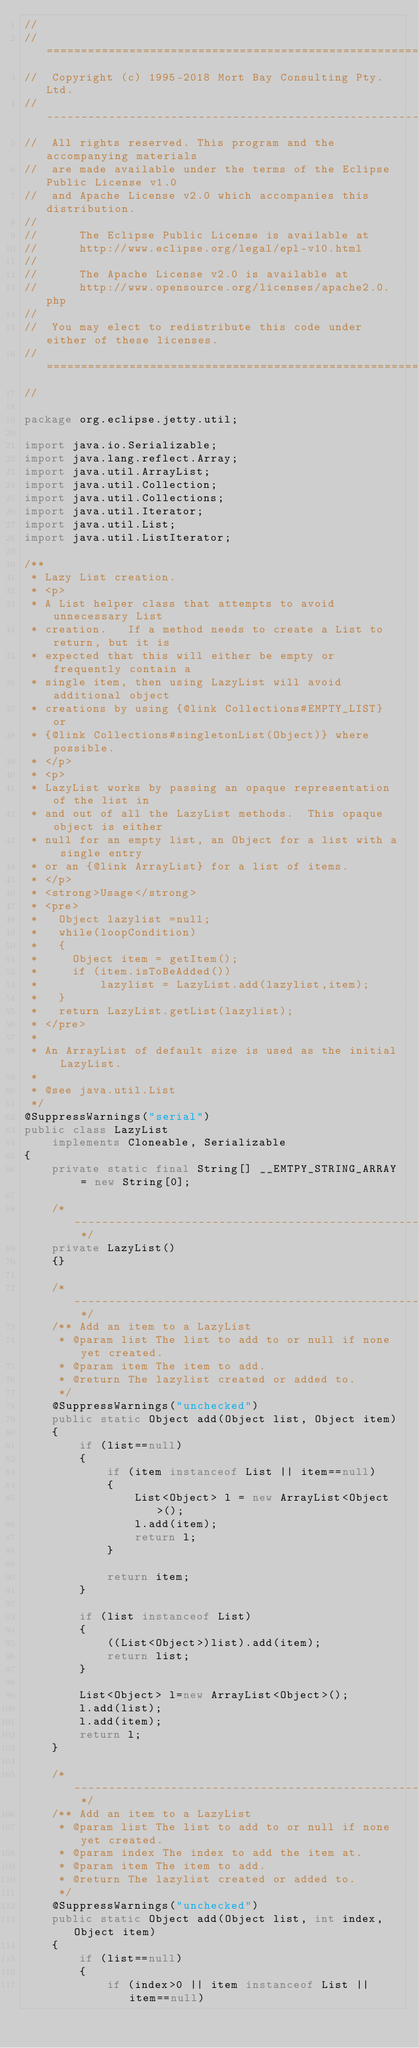<code> <loc_0><loc_0><loc_500><loc_500><_Java_>//
//  ========================================================================
//  Copyright (c) 1995-2018 Mort Bay Consulting Pty. Ltd.
//  ------------------------------------------------------------------------
//  All rights reserved. This program and the accompanying materials
//  are made available under the terms of the Eclipse Public License v1.0
//  and Apache License v2.0 which accompanies this distribution.
//
//      The Eclipse Public License is available at
//      http://www.eclipse.org/legal/epl-v10.html
//
//      The Apache License v2.0 is available at
//      http://www.opensource.org/licenses/apache2.0.php
//
//  You may elect to redistribute this code under either of these licenses.
//  ========================================================================
//

package org.eclipse.jetty.util;

import java.io.Serializable;
import java.lang.reflect.Array;
import java.util.ArrayList;
import java.util.Collection;
import java.util.Collections;
import java.util.Iterator;
import java.util.List;
import java.util.ListIterator;

/** 
 * Lazy List creation.
 * <p>
 * A List helper class that attempts to avoid unnecessary List
 * creation.   If a method needs to create a List to return, but it is
 * expected that this will either be empty or frequently contain a
 * single item, then using LazyList will avoid additional object
 * creations by using {@link Collections#EMPTY_LIST} or
 * {@link Collections#singletonList(Object)} where possible.
 * </p>
 * <p>
 * LazyList works by passing an opaque representation of the list in
 * and out of all the LazyList methods.  This opaque object is either
 * null for an empty list, an Object for a list with a single entry
 * or an {@link ArrayList} for a list of items.
 * </p>
 * <strong>Usage</strong>
 * <pre>
 *   Object lazylist =null;
 *   while(loopCondition)
 *   {
 *     Object item = getItem();
 *     if (item.isToBeAdded())
 *         lazylist = LazyList.add(lazylist,item);
 *   }
 *   return LazyList.getList(lazylist);
 * </pre>
 *
 * An ArrayList of default size is used as the initial LazyList.
 *
 * @see java.util.List
 */
@SuppressWarnings("serial")
public class LazyList
    implements Cloneable, Serializable
{
    private static final String[] __EMTPY_STRING_ARRAY = new String[0];
    
    /* ------------------------------------------------------------ */
    private LazyList()
    {}
    
    /* ------------------------------------------------------------ */
    /** Add an item to a LazyList 
     * @param list The list to add to or null if none yet created.
     * @param item The item to add.
     * @return The lazylist created or added to.
     */
    @SuppressWarnings("unchecked")
    public static Object add(Object list, Object item)
    {
        if (list==null)
        {
            if (item instanceof List || item==null)
            {
                List<Object> l = new ArrayList<Object>();
                l.add(item);
                return l;
            }

            return item;
        }

        if (list instanceof List)
        {
            ((List<Object>)list).add(item);
            return list;
        }

        List<Object> l=new ArrayList<Object>();
        l.add(list);
        l.add(item);
        return l;    
    }

    /* ------------------------------------------------------------ */
    /** Add an item to a LazyList 
     * @param list The list to add to or null if none yet created.
     * @param index The index to add the item at.
     * @param item The item to add.
     * @return The lazylist created or added to.
     */
    @SuppressWarnings("unchecked")
    public static Object add(Object list, int index, Object item)
    {
        if (list==null)
        {
            if (index>0 || item instanceof List || item==null)</code> 